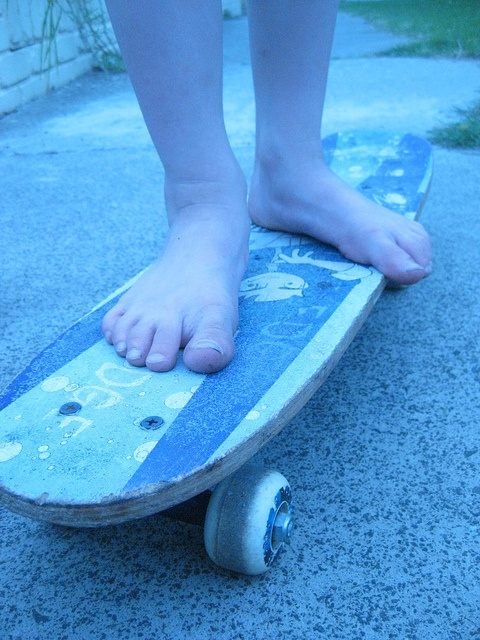Describe the objects in this image and their specific colors. I can see skateboard in lightblue tones and people in lightblue and gray tones in this image. 